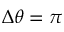Convert formula to latex. <formula><loc_0><loc_0><loc_500><loc_500>\Delta \theta = \pi</formula> 